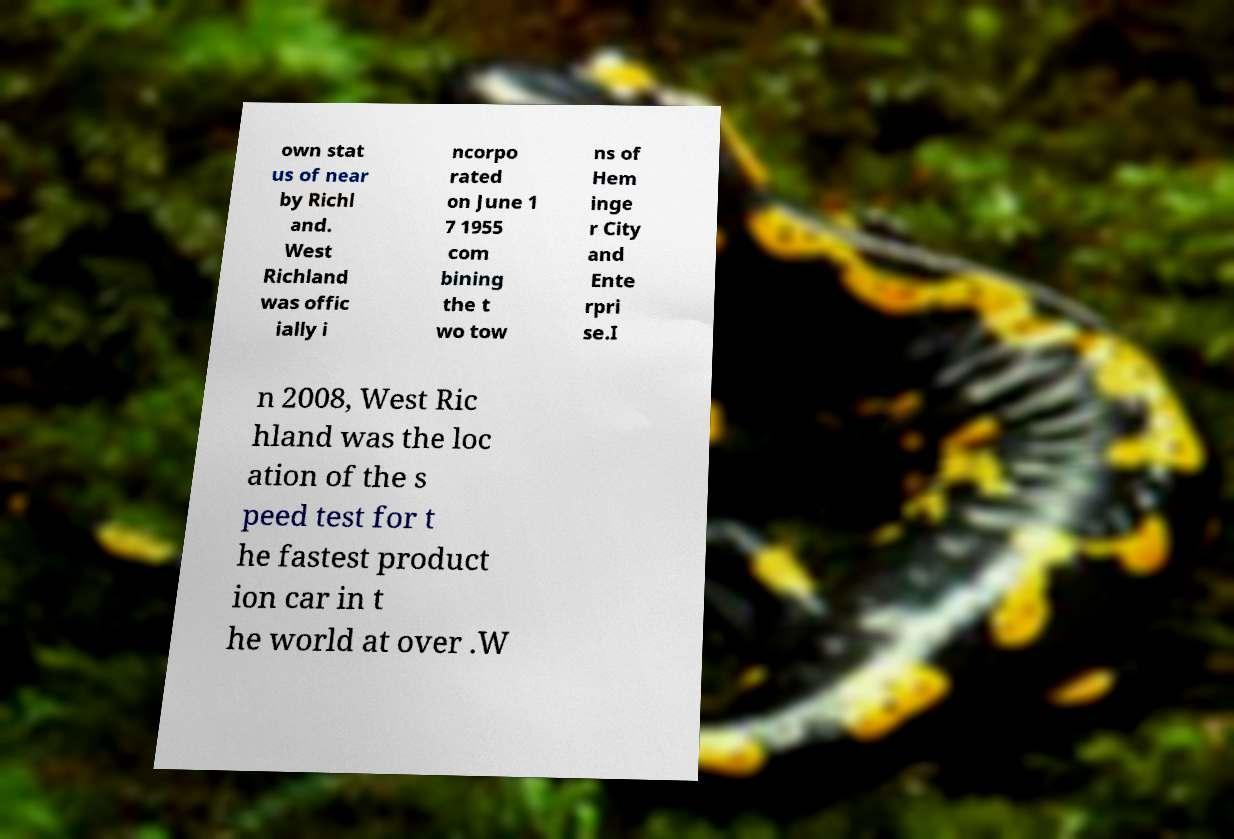Could you assist in decoding the text presented in this image and type it out clearly? own stat us of near by Richl and. West Richland was offic ially i ncorpo rated on June 1 7 1955 com bining the t wo tow ns of Hem inge r City and Ente rpri se.I n 2008, West Ric hland was the loc ation of the s peed test for t he fastest product ion car in t he world at over .W 